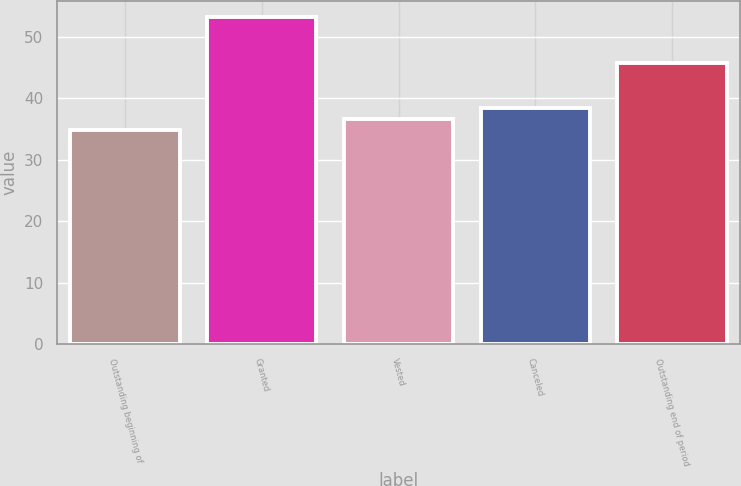Convert chart to OTSL. <chart><loc_0><loc_0><loc_500><loc_500><bar_chart><fcel>Outstanding beginning of<fcel>Granted<fcel>Vested<fcel>Canceled<fcel>Outstanding end of period<nl><fcel>34.81<fcel>53.16<fcel>36.65<fcel>38.48<fcel>45.72<nl></chart> 